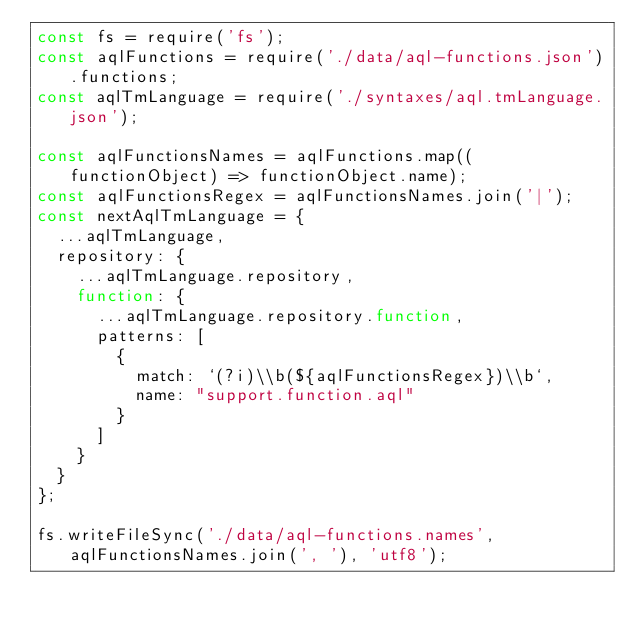Convert code to text. <code><loc_0><loc_0><loc_500><loc_500><_JavaScript_>const fs = require('fs');
const aqlFunctions = require('./data/aql-functions.json').functions;
const aqlTmLanguage = require('./syntaxes/aql.tmLanguage.json');

const aqlFunctionsNames = aqlFunctions.map((functionObject) => functionObject.name);
const aqlFunctionsRegex = aqlFunctionsNames.join('|');
const nextAqlTmLanguage = {
  ...aqlTmLanguage,
  repository: {
    ...aqlTmLanguage.repository,
    function: {
      ...aqlTmLanguage.repository.function,
      patterns: [
        {
          match: `(?i)\\b(${aqlFunctionsRegex})\\b`,
          name: "support.function.aql"
        }
      ]
    }
  }
};

fs.writeFileSync('./data/aql-functions.names', aqlFunctionsNames.join(', '), 'utf8');</code> 